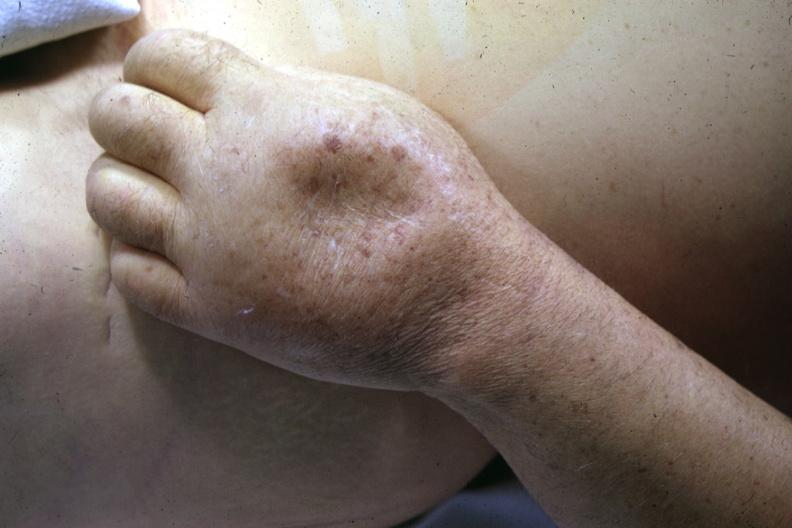where is this?
Answer the question using a single word or phrase. Skin 